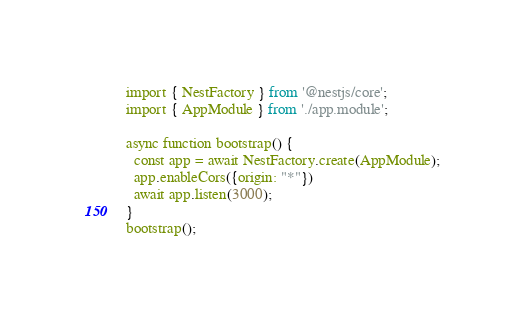Convert code to text. <code><loc_0><loc_0><loc_500><loc_500><_TypeScript_>import { NestFactory } from '@nestjs/core';
import { AppModule } from './app.module';

async function bootstrap() {
  const app = await NestFactory.create(AppModule);
  app.enableCors({origin: "*"})
  await app.listen(3000);
}
bootstrap();

</code> 